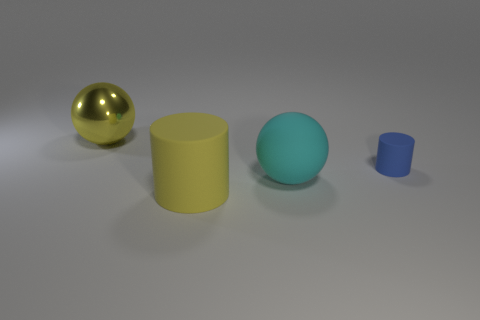Is there any other thing that is made of the same material as the yellow ball?
Provide a short and direct response. No. There is a cylinder that is the same color as the big metal object; what material is it?
Make the answer very short. Rubber. There is another object that is the same shape as the large shiny object; what is its size?
Keep it short and to the point. Large. Are the thing behind the small blue matte cylinder and the blue object made of the same material?
Offer a very short reply. No. Is the blue thing the same shape as the big cyan matte thing?
Your response must be concise. No. How many objects are large things on the right side of the big rubber cylinder or big yellow cylinders?
Your response must be concise. 2. What size is the yellow cylinder that is the same material as the cyan thing?
Offer a very short reply. Large. What number of other small things are the same color as the tiny thing?
Your response must be concise. 0. How many big objects are shiny spheres or yellow cylinders?
Provide a succinct answer. 2. There is a rubber object that is the same color as the metallic sphere; what size is it?
Your response must be concise. Large. 